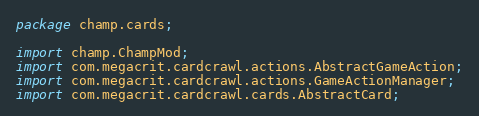<code> <loc_0><loc_0><loc_500><loc_500><_Java_>package champ.cards;

import champ.ChampMod;
import com.megacrit.cardcrawl.actions.AbstractGameAction;
import com.megacrit.cardcrawl.actions.GameActionManager;
import com.megacrit.cardcrawl.cards.AbstractCard;</code> 